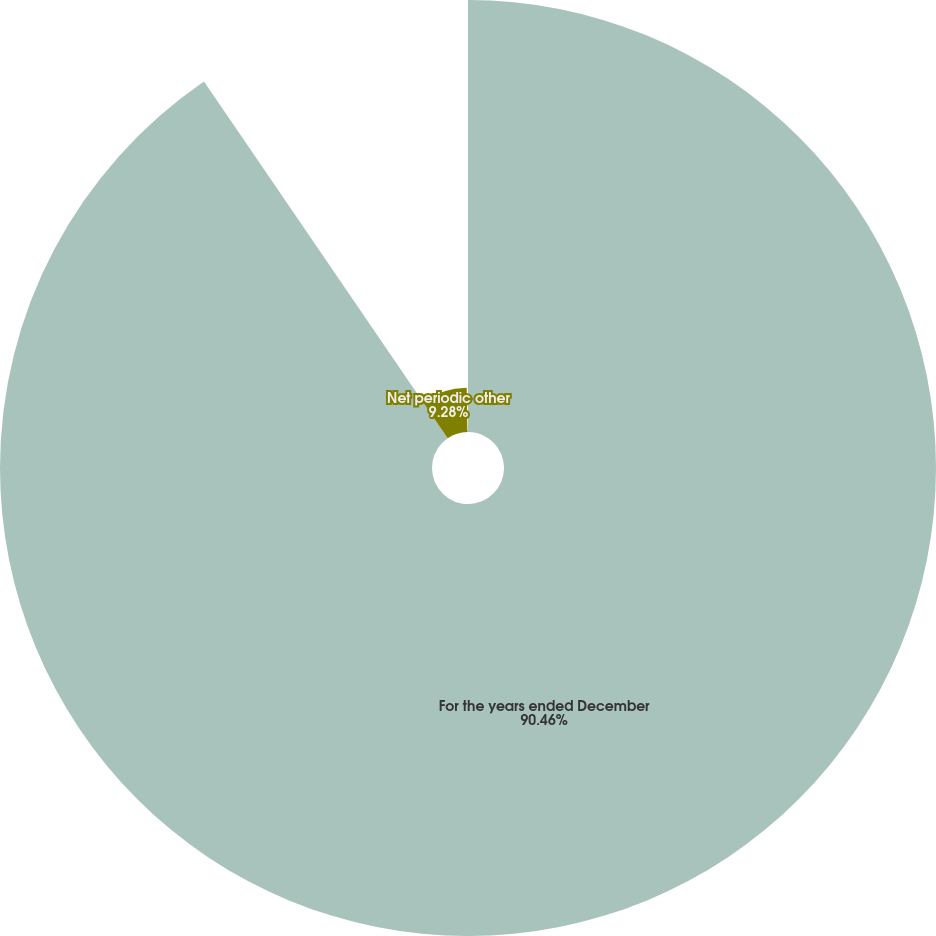Convert chart. <chart><loc_0><loc_0><loc_500><loc_500><pie_chart><fcel>For the years ended December<fcel>Net periodic other<fcel>Average discount rate<nl><fcel>90.47%<fcel>9.28%<fcel>0.26%<nl></chart> 